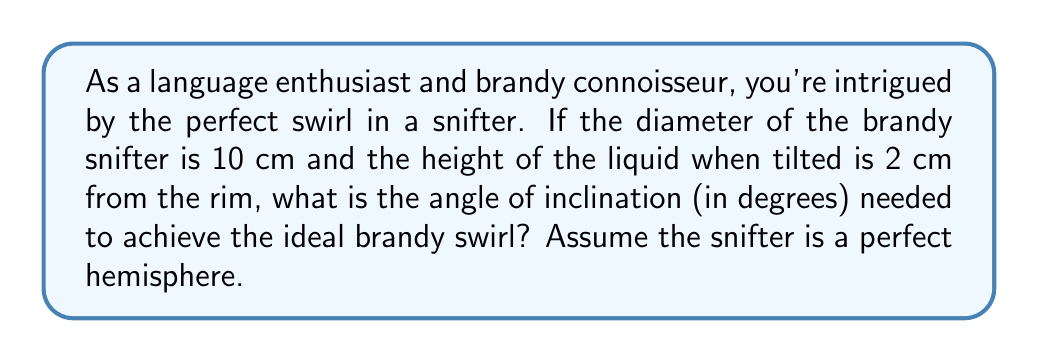What is the answer to this math problem? Let's approach this step-by-step:

1) In a hemisphere, the radius (r) is half the diameter. So, $r = 5$ cm.

2) The height of the liquid from the bottom of the snifter is $h = r - 2 = 3$ cm.

3) In a right-angled triangle formed by the tilted liquid surface:
   - The hypotenuse is the radius (5 cm)
   - The opposite side is the height difference (3 cm)

4) We can use the arcsine function to find the angle:

   $$\theta = \arcsin(\frac{\text{opposite}}{\text{hypotenuse}}) = \arcsin(\frac{3}{5})$$

5) Calculate:
   $$\theta = \arcsin(0.6) \approx 36.87^\circ$$

6) The angle of inclination is the complement of this angle:

   $$\text{Angle of inclination} = 90^\circ - 36.87^\circ \approx 53.13^\circ$$

[asy]
import geometry;

size(200);
pair O=(0,0);
real r=5;
draw(Circle(O,r));
draw((-r,0)--(r,0));
real h=3;
pair A=(-sqrt(r^2-h^2),h);
pair B=(sqrt(r^2-h^2),h);
draw(A--B);
draw(O--A);
draw(O--B);
label("53.13°",O,NE);
label("5 cm",O--A,NE);
label("3 cm",(-5,3)--(0,3),W);
[/asy]
Answer: $53.13^\circ$ 